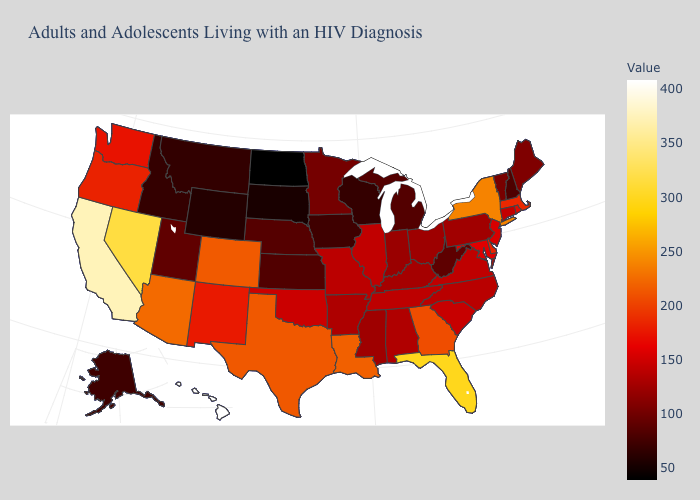Among the states that border New Hampshire , which have the highest value?
Keep it brief. Massachusetts. Does New Hampshire have the lowest value in the Northeast?
Be succinct. Yes. Which states have the lowest value in the USA?
Concise answer only. North Dakota. Does New Jersey have the lowest value in the USA?
Write a very short answer. No. Does Louisiana have a higher value than Montana?
Be succinct. Yes. Among the states that border Wyoming , does Colorado have the lowest value?
Give a very brief answer. No. 